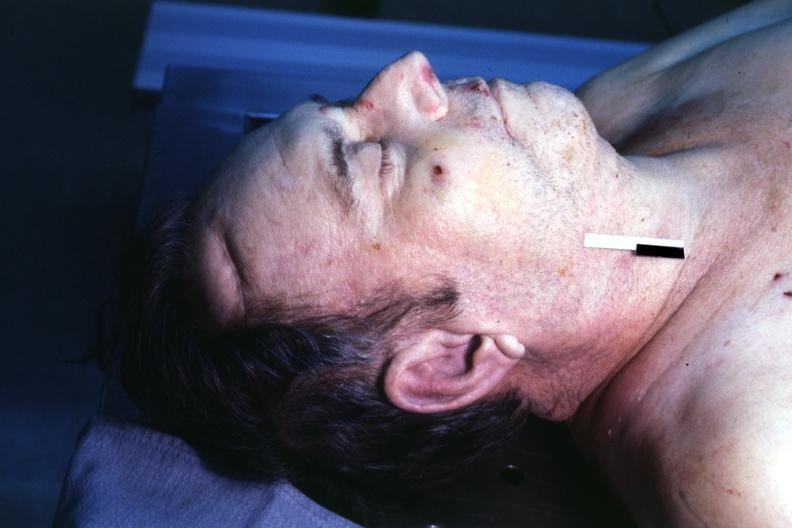what is present?
Answer the question using a single word or phrase. Ear lobe horizontal crease 